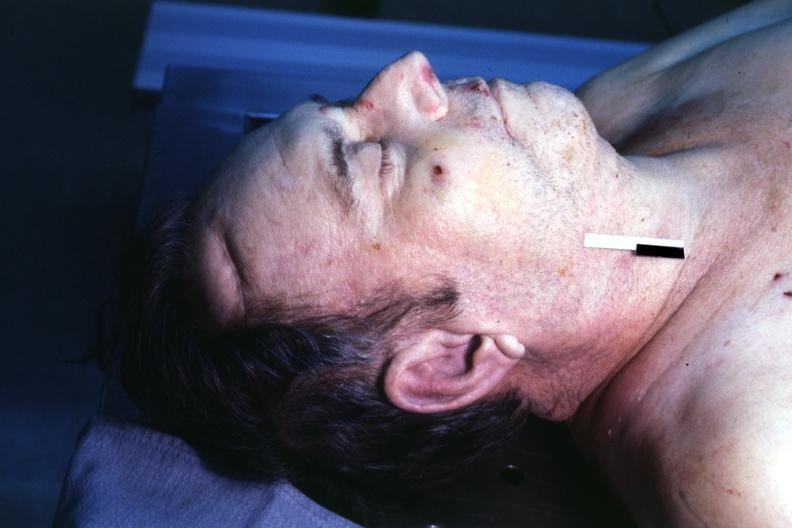what is present?
Answer the question using a single word or phrase. Ear lobe horizontal crease 